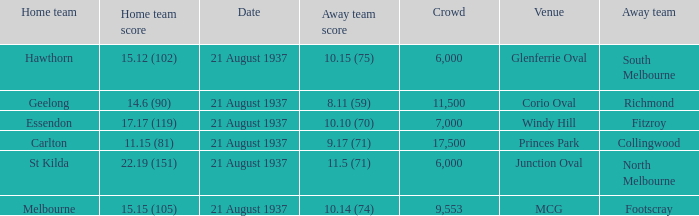Where does South Melbourne play? Glenferrie Oval. 